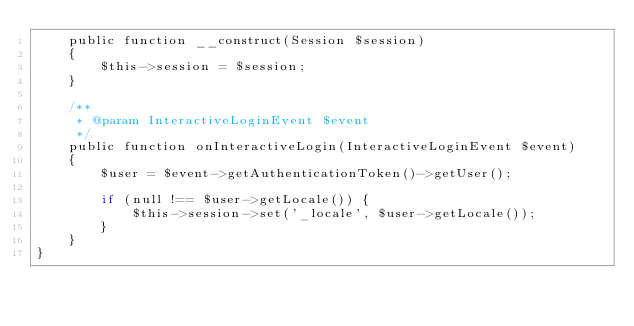<code> <loc_0><loc_0><loc_500><loc_500><_PHP_>    public function __construct(Session $session)
    {
        $this->session = $session;
    }

    /**
     * @param InteractiveLoginEvent $event
     */
    public function onInteractiveLogin(InteractiveLoginEvent $event)
    {
        $user = $event->getAuthenticationToken()->getUser();

        if (null !== $user->getLocale()) {
            $this->session->set('_locale', $user->getLocale());
        }
    }
}</code> 